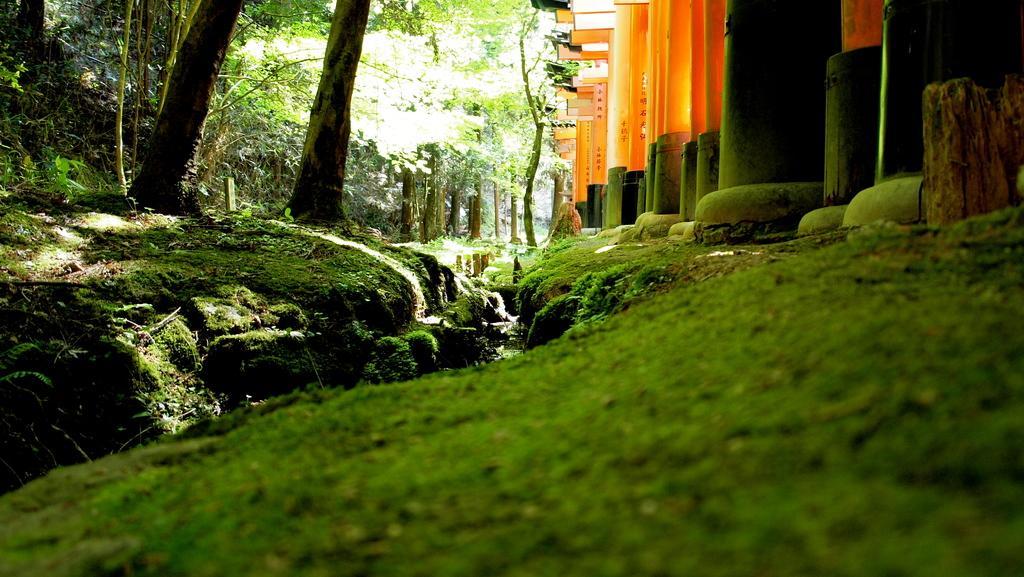Could you give a brief overview of what you see in this image? At the bottom of the image there is grass on the surface. On the right side of the image there are pillars. On the left side of the image there are trees. 